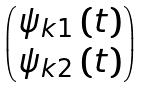<formula> <loc_0><loc_0><loc_500><loc_500>\begin{pmatrix} \psi _ { k 1 } \left ( t \right ) \\ \psi _ { k 2 } \left ( t \right ) \end{pmatrix}</formula> 